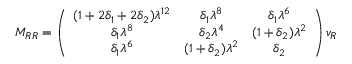<formula> <loc_0><loc_0><loc_500><loc_500>M _ { R R } = \left ( \begin{array} { c c c } { { ( 1 + 2 \delta _ { 1 } + 2 \delta _ { 2 } ) \lambda ^ { 1 2 } } } & { { \delta _ { 1 } \lambda ^ { 8 } } } & { { \delta _ { 1 } \lambda ^ { 6 } } } \\ { { \delta _ { 1 } \lambda ^ { 8 } } } & { { \delta _ { 2 } \lambda ^ { 4 } } } & { { ( 1 + \delta _ { 2 } ) \lambda ^ { 2 } } } \\ { { \delta _ { 1 } \lambda ^ { 6 } } } & { { ( 1 + \delta _ { 2 } ) \lambda ^ { 2 } } } & { { \delta _ { 2 } } } \end{array} \right ) v _ { R }</formula> 